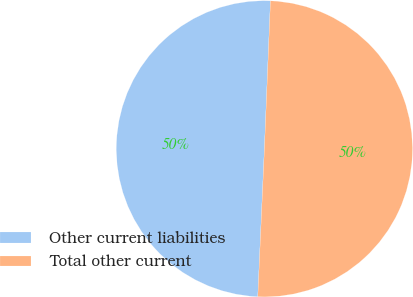Convert chart to OTSL. <chart><loc_0><loc_0><loc_500><loc_500><pie_chart><fcel>Other current liabilities<fcel>Total other current<nl><fcel>49.94%<fcel>50.06%<nl></chart> 